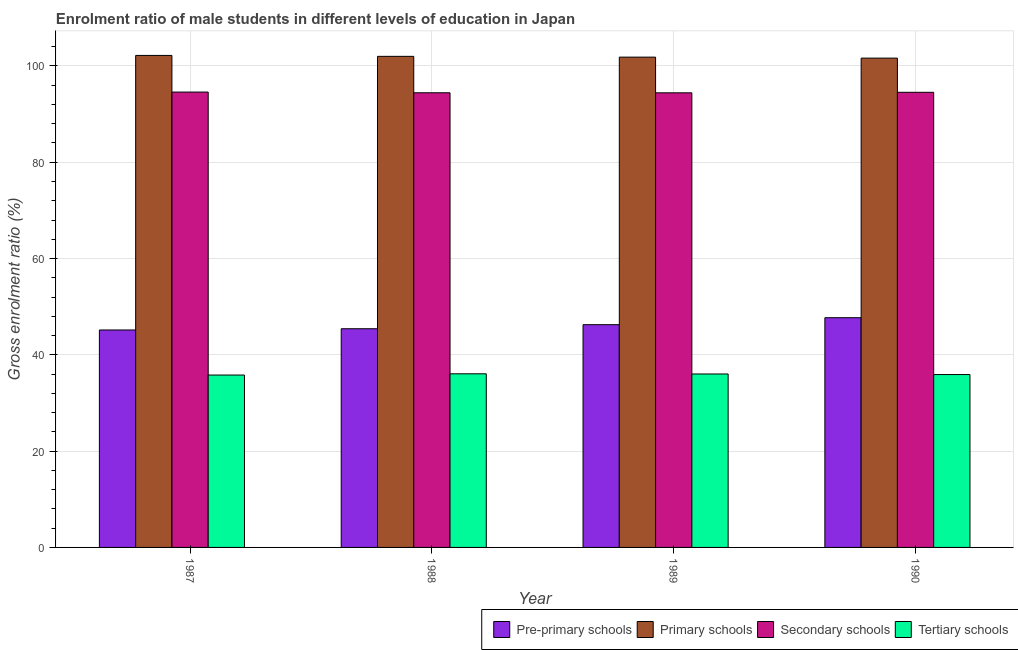How many groups of bars are there?
Ensure brevity in your answer.  4. Are the number of bars per tick equal to the number of legend labels?
Your answer should be compact. Yes. How many bars are there on the 3rd tick from the right?
Ensure brevity in your answer.  4. In how many cases, is the number of bars for a given year not equal to the number of legend labels?
Ensure brevity in your answer.  0. What is the gross enrolment ratio(female) in secondary schools in 1988?
Make the answer very short. 94.42. Across all years, what is the maximum gross enrolment ratio(female) in primary schools?
Provide a succinct answer. 102.18. Across all years, what is the minimum gross enrolment ratio(female) in tertiary schools?
Make the answer very short. 35.8. In which year was the gross enrolment ratio(female) in pre-primary schools minimum?
Offer a terse response. 1987. What is the total gross enrolment ratio(female) in primary schools in the graph?
Keep it short and to the point. 407.61. What is the difference between the gross enrolment ratio(female) in tertiary schools in 1988 and that in 1989?
Your answer should be very brief. 0.04. What is the difference between the gross enrolment ratio(female) in tertiary schools in 1988 and the gross enrolment ratio(female) in primary schools in 1987?
Your response must be concise. 0.26. What is the average gross enrolment ratio(female) in pre-primary schools per year?
Make the answer very short. 46.14. What is the ratio of the gross enrolment ratio(female) in tertiary schools in 1989 to that in 1990?
Make the answer very short. 1. Is the gross enrolment ratio(female) in secondary schools in 1987 less than that in 1988?
Offer a terse response. No. Is the difference between the gross enrolment ratio(female) in tertiary schools in 1989 and 1990 greater than the difference between the gross enrolment ratio(female) in primary schools in 1989 and 1990?
Ensure brevity in your answer.  No. What is the difference between the highest and the second highest gross enrolment ratio(female) in tertiary schools?
Ensure brevity in your answer.  0.04. What is the difference between the highest and the lowest gross enrolment ratio(female) in primary schools?
Ensure brevity in your answer.  0.56. Is the sum of the gross enrolment ratio(female) in tertiary schools in 1987 and 1988 greater than the maximum gross enrolment ratio(female) in primary schools across all years?
Your answer should be very brief. Yes. What does the 3rd bar from the left in 1987 represents?
Your answer should be very brief. Secondary schools. What does the 1st bar from the right in 1987 represents?
Give a very brief answer. Tertiary schools. Is it the case that in every year, the sum of the gross enrolment ratio(female) in pre-primary schools and gross enrolment ratio(female) in primary schools is greater than the gross enrolment ratio(female) in secondary schools?
Provide a succinct answer. Yes. Are all the bars in the graph horizontal?
Make the answer very short. No. How many years are there in the graph?
Provide a short and direct response. 4. What is the difference between two consecutive major ticks on the Y-axis?
Your answer should be very brief. 20. Are the values on the major ticks of Y-axis written in scientific E-notation?
Ensure brevity in your answer.  No. What is the title of the graph?
Your answer should be compact. Enrolment ratio of male students in different levels of education in Japan. What is the label or title of the Y-axis?
Your answer should be very brief. Gross enrolment ratio (%). What is the Gross enrolment ratio (%) in Pre-primary schools in 1987?
Provide a succinct answer. 45.16. What is the Gross enrolment ratio (%) of Primary schools in 1987?
Offer a very short reply. 102.18. What is the Gross enrolment ratio (%) in Secondary schools in 1987?
Make the answer very short. 94.57. What is the Gross enrolment ratio (%) in Tertiary schools in 1987?
Keep it short and to the point. 35.8. What is the Gross enrolment ratio (%) in Pre-primary schools in 1988?
Keep it short and to the point. 45.42. What is the Gross enrolment ratio (%) in Primary schools in 1988?
Keep it short and to the point. 101.99. What is the Gross enrolment ratio (%) in Secondary schools in 1988?
Offer a very short reply. 94.42. What is the Gross enrolment ratio (%) of Tertiary schools in 1988?
Make the answer very short. 36.06. What is the Gross enrolment ratio (%) in Pre-primary schools in 1989?
Offer a terse response. 46.26. What is the Gross enrolment ratio (%) of Primary schools in 1989?
Your response must be concise. 101.82. What is the Gross enrolment ratio (%) in Secondary schools in 1989?
Give a very brief answer. 94.41. What is the Gross enrolment ratio (%) of Tertiary schools in 1989?
Offer a terse response. 36.02. What is the Gross enrolment ratio (%) in Pre-primary schools in 1990?
Ensure brevity in your answer.  47.71. What is the Gross enrolment ratio (%) of Primary schools in 1990?
Your answer should be compact. 101.62. What is the Gross enrolment ratio (%) in Secondary schools in 1990?
Your answer should be very brief. 94.52. What is the Gross enrolment ratio (%) in Tertiary schools in 1990?
Make the answer very short. 35.9. Across all years, what is the maximum Gross enrolment ratio (%) of Pre-primary schools?
Provide a short and direct response. 47.71. Across all years, what is the maximum Gross enrolment ratio (%) in Primary schools?
Offer a very short reply. 102.18. Across all years, what is the maximum Gross enrolment ratio (%) of Secondary schools?
Ensure brevity in your answer.  94.57. Across all years, what is the maximum Gross enrolment ratio (%) of Tertiary schools?
Make the answer very short. 36.06. Across all years, what is the minimum Gross enrolment ratio (%) of Pre-primary schools?
Offer a very short reply. 45.16. Across all years, what is the minimum Gross enrolment ratio (%) in Primary schools?
Provide a succinct answer. 101.62. Across all years, what is the minimum Gross enrolment ratio (%) of Secondary schools?
Give a very brief answer. 94.41. Across all years, what is the minimum Gross enrolment ratio (%) of Tertiary schools?
Provide a succinct answer. 35.8. What is the total Gross enrolment ratio (%) in Pre-primary schools in the graph?
Keep it short and to the point. 184.54. What is the total Gross enrolment ratio (%) in Primary schools in the graph?
Provide a succinct answer. 407.61. What is the total Gross enrolment ratio (%) in Secondary schools in the graph?
Your answer should be very brief. 377.93. What is the total Gross enrolment ratio (%) of Tertiary schools in the graph?
Your response must be concise. 143.78. What is the difference between the Gross enrolment ratio (%) of Pre-primary schools in 1987 and that in 1988?
Your answer should be compact. -0.26. What is the difference between the Gross enrolment ratio (%) in Primary schools in 1987 and that in 1988?
Provide a succinct answer. 0.19. What is the difference between the Gross enrolment ratio (%) in Secondary schools in 1987 and that in 1988?
Ensure brevity in your answer.  0.15. What is the difference between the Gross enrolment ratio (%) in Tertiary schools in 1987 and that in 1988?
Provide a succinct answer. -0.26. What is the difference between the Gross enrolment ratio (%) of Pre-primary schools in 1987 and that in 1989?
Your answer should be compact. -1.1. What is the difference between the Gross enrolment ratio (%) in Primary schools in 1987 and that in 1989?
Ensure brevity in your answer.  0.36. What is the difference between the Gross enrolment ratio (%) of Secondary schools in 1987 and that in 1989?
Provide a succinct answer. 0.16. What is the difference between the Gross enrolment ratio (%) in Tertiary schools in 1987 and that in 1989?
Your response must be concise. -0.22. What is the difference between the Gross enrolment ratio (%) of Pre-primary schools in 1987 and that in 1990?
Make the answer very short. -2.55. What is the difference between the Gross enrolment ratio (%) in Primary schools in 1987 and that in 1990?
Provide a succinct answer. 0.56. What is the difference between the Gross enrolment ratio (%) in Secondary schools in 1987 and that in 1990?
Ensure brevity in your answer.  0.05. What is the difference between the Gross enrolment ratio (%) of Tertiary schools in 1987 and that in 1990?
Ensure brevity in your answer.  -0.1. What is the difference between the Gross enrolment ratio (%) of Pre-primary schools in 1988 and that in 1989?
Your answer should be very brief. -0.84. What is the difference between the Gross enrolment ratio (%) of Primary schools in 1988 and that in 1989?
Your response must be concise. 0.16. What is the difference between the Gross enrolment ratio (%) in Secondary schools in 1988 and that in 1989?
Offer a very short reply. 0.01. What is the difference between the Gross enrolment ratio (%) in Tertiary schools in 1988 and that in 1989?
Ensure brevity in your answer.  0.04. What is the difference between the Gross enrolment ratio (%) of Pre-primary schools in 1988 and that in 1990?
Your response must be concise. -2.29. What is the difference between the Gross enrolment ratio (%) of Primary schools in 1988 and that in 1990?
Ensure brevity in your answer.  0.37. What is the difference between the Gross enrolment ratio (%) of Secondary schools in 1988 and that in 1990?
Give a very brief answer. -0.1. What is the difference between the Gross enrolment ratio (%) in Tertiary schools in 1988 and that in 1990?
Your answer should be very brief. 0.15. What is the difference between the Gross enrolment ratio (%) in Pre-primary schools in 1989 and that in 1990?
Provide a short and direct response. -1.45. What is the difference between the Gross enrolment ratio (%) of Primary schools in 1989 and that in 1990?
Give a very brief answer. 0.2. What is the difference between the Gross enrolment ratio (%) in Secondary schools in 1989 and that in 1990?
Keep it short and to the point. -0.11. What is the difference between the Gross enrolment ratio (%) of Tertiary schools in 1989 and that in 1990?
Provide a short and direct response. 0.12. What is the difference between the Gross enrolment ratio (%) of Pre-primary schools in 1987 and the Gross enrolment ratio (%) of Primary schools in 1988?
Your answer should be compact. -56.83. What is the difference between the Gross enrolment ratio (%) in Pre-primary schools in 1987 and the Gross enrolment ratio (%) in Secondary schools in 1988?
Offer a very short reply. -49.26. What is the difference between the Gross enrolment ratio (%) in Pre-primary schools in 1987 and the Gross enrolment ratio (%) in Tertiary schools in 1988?
Make the answer very short. 9.1. What is the difference between the Gross enrolment ratio (%) in Primary schools in 1987 and the Gross enrolment ratio (%) in Secondary schools in 1988?
Offer a terse response. 7.76. What is the difference between the Gross enrolment ratio (%) in Primary schools in 1987 and the Gross enrolment ratio (%) in Tertiary schools in 1988?
Offer a very short reply. 66.12. What is the difference between the Gross enrolment ratio (%) in Secondary schools in 1987 and the Gross enrolment ratio (%) in Tertiary schools in 1988?
Your answer should be very brief. 58.51. What is the difference between the Gross enrolment ratio (%) of Pre-primary schools in 1987 and the Gross enrolment ratio (%) of Primary schools in 1989?
Keep it short and to the point. -56.66. What is the difference between the Gross enrolment ratio (%) of Pre-primary schools in 1987 and the Gross enrolment ratio (%) of Secondary schools in 1989?
Your response must be concise. -49.25. What is the difference between the Gross enrolment ratio (%) of Pre-primary schools in 1987 and the Gross enrolment ratio (%) of Tertiary schools in 1989?
Your answer should be very brief. 9.14. What is the difference between the Gross enrolment ratio (%) in Primary schools in 1987 and the Gross enrolment ratio (%) in Secondary schools in 1989?
Offer a very short reply. 7.77. What is the difference between the Gross enrolment ratio (%) of Primary schools in 1987 and the Gross enrolment ratio (%) of Tertiary schools in 1989?
Make the answer very short. 66.16. What is the difference between the Gross enrolment ratio (%) of Secondary schools in 1987 and the Gross enrolment ratio (%) of Tertiary schools in 1989?
Your answer should be very brief. 58.55. What is the difference between the Gross enrolment ratio (%) of Pre-primary schools in 1987 and the Gross enrolment ratio (%) of Primary schools in 1990?
Make the answer very short. -56.46. What is the difference between the Gross enrolment ratio (%) in Pre-primary schools in 1987 and the Gross enrolment ratio (%) in Secondary schools in 1990?
Ensure brevity in your answer.  -49.36. What is the difference between the Gross enrolment ratio (%) in Pre-primary schools in 1987 and the Gross enrolment ratio (%) in Tertiary schools in 1990?
Offer a very short reply. 9.26. What is the difference between the Gross enrolment ratio (%) in Primary schools in 1987 and the Gross enrolment ratio (%) in Secondary schools in 1990?
Make the answer very short. 7.66. What is the difference between the Gross enrolment ratio (%) of Primary schools in 1987 and the Gross enrolment ratio (%) of Tertiary schools in 1990?
Your response must be concise. 66.28. What is the difference between the Gross enrolment ratio (%) in Secondary schools in 1987 and the Gross enrolment ratio (%) in Tertiary schools in 1990?
Keep it short and to the point. 58.67. What is the difference between the Gross enrolment ratio (%) in Pre-primary schools in 1988 and the Gross enrolment ratio (%) in Primary schools in 1989?
Your response must be concise. -56.41. What is the difference between the Gross enrolment ratio (%) of Pre-primary schools in 1988 and the Gross enrolment ratio (%) of Secondary schools in 1989?
Give a very brief answer. -49. What is the difference between the Gross enrolment ratio (%) in Pre-primary schools in 1988 and the Gross enrolment ratio (%) in Tertiary schools in 1989?
Your answer should be very brief. 9.39. What is the difference between the Gross enrolment ratio (%) in Primary schools in 1988 and the Gross enrolment ratio (%) in Secondary schools in 1989?
Your answer should be very brief. 7.57. What is the difference between the Gross enrolment ratio (%) in Primary schools in 1988 and the Gross enrolment ratio (%) in Tertiary schools in 1989?
Your response must be concise. 65.96. What is the difference between the Gross enrolment ratio (%) of Secondary schools in 1988 and the Gross enrolment ratio (%) of Tertiary schools in 1989?
Give a very brief answer. 58.4. What is the difference between the Gross enrolment ratio (%) in Pre-primary schools in 1988 and the Gross enrolment ratio (%) in Primary schools in 1990?
Your answer should be very brief. -56.2. What is the difference between the Gross enrolment ratio (%) in Pre-primary schools in 1988 and the Gross enrolment ratio (%) in Secondary schools in 1990?
Ensure brevity in your answer.  -49.11. What is the difference between the Gross enrolment ratio (%) of Pre-primary schools in 1988 and the Gross enrolment ratio (%) of Tertiary schools in 1990?
Offer a terse response. 9.51. What is the difference between the Gross enrolment ratio (%) in Primary schools in 1988 and the Gross enrolment ratio (%) in Secondary schools in 1990?
Your answer should be compact. 7.46. What is the difference between the Gross enrolment ratio (%) of Primary schools in 1988 and the Gross enrolment ratio (%) of Tertiary schools in 1990?
Make the answer very short. 66.08. What is the difference between the Gross enrolment ratio (%) of Secondary schools in 1988 and the Gross enrolment ratio (%) of Tertiary schools in 1990?
Your response must be concise. 58.52. What is the difference between the Gross enrolment ratio (%) in Pre-primary schools in 1989 and the Gross enrolment ratio (%) in Primary schools in 1990?
Your answer should be very brief. -55.36. What is the difference between the Gross enrolment ratio (%) in Pre-primary schools in 1989 and the Gross enrolment ratio (%) in Secondary schools in 1990?
Provide a short and direct response. -48.26. What is the difference between the Gross enrolment ratio (%) in Pre-primary schools in 1989 and the Gross enrolment ratio (%) in Tertiary schools in 1990?
Your answer should be compact. 10.36. What is the difference between the Gross enrolment ratio (%) in Primary schools in 1989 and the Gross enrolment ratio (%) in Secondary schools in 1990?
Your response must be concise. 7.3. What is the difference between the Gross enrolment ratio (%) of Primary schools in 1989 and the Gross enrolment ratio (%) of Tertiary schools in 1990?
Your response must be concise. 65.92. What is the difference between the Gross enrolment ratio (%) in Secondary schools in 1989 and the Gross enrolment ratio (%) in Tertiary schools in 1990?
Offer a very short reply. 58.51. What is the average Gross enrolment ratio (%) in Pre-primary schools per year?
Provide a succinct answer. 46.14. What is the average Gross enrolment ratio (%) in Primary schools per year?
Provide a short and direct response. 101.9. What is the average Gross enrolment ratio (%) of Secondary schools per year?
Offer a terse response. 94.48. What is the average Gross enrolment ratio (%) of Tertiary schools per year?
Make the answer very short. 35.95. In the year 1987, what is the difference between the Gross enrolment ratio (%) in Pre-primary schools and Gross enrolment ratio (%) in Primary schools?
Your response must be concise. -57.02. In the year 1987, what is the difference between the Gross enrolment ratio (%) in Pre-primary schools and Gross enrolment ratio (%) in Secondary schools?
Your answer should be compact. -49.41. In the year 1987, what is the difference between the Gross enrolment ratio (%) in Pre-primary schools and Gross enrolment ratio (%) in Tertiary schools?
Your response must be concise. 9.36. In the year 1987, what is the difference between the Gross enrolment ratio (%) in Primary schools and Gross enrolment ratio (%) in Secondary schools?
Offer a terse response. 7.61. In the year 1987, what is the difference between the Gross enrolment ratio (%) in Primary schools and Gross enrolment ratio (%) in Tertiary schools?
Make the answer very short. 66.38. In the year 1987, what is the difference between the Gross enrolment ratio (%) in Secondary schools and Gross enrolment ratio (%) in Tertiary schools?
Give a very brief answer. 58.77. In the year 1988, what is the difference between the Gross enrolment ratio (%) of Pre-primary schools and Gross enrolment ratio (%) of Primary schools?
Give a very brief answer. -56.57. In the year 1988, what is the difference between the Gross enrolment ratio (%) in Pre-primary schools and Gross enrolment ratio (%) in Secondary schools?
Provide a succinct answer. -49.01. In the year 1988, what is the difference between the Gross enrolment ratio (%) in Pre-primary schools and Gross enrolment ratio (%) in Tertiary schools?
Ensure brevity in your answer.  9.36. In the year 1988, what is the difference between the Gross enrolment ratio (%) in Primary schools and Gross enrolment ratio (%) in Secondary schools?
Provide a succinct answer. 7.56. In the year 1988, what is the difference between the Gross enrolment ratio (%) in Primary schools and Gross enrolment ratio (%) in Tertiary schools?
Your answer should be compact. 65.93. In the year 1988, what is the difference between the Gross enrolment ratio (%) of Secondary schools and Gross enrolment ratio (%) of Tertiary schools?
Provide a succinct answer. 58.37. In the year 1989, what is the difference between the Gross enrolment ratio (%) in Pre-primary schools and Gross enrolment ratio (%) in Primary schools?
Your answer should be very brief. -55.56. In the year 1989, what is the difference between the Gross enrolment ratio (%) of Pre-primary schools and Gross enrolment ratio (%) of Secondary schools?
Offer a very short reply. -48.15. In the year 1989, what is the difference between the Gross enrolment ratio (%) in Pre-primary schools and Gross enrolment ratio (%) in Tertiary schools?
Keep it short and to the point. 10.24. In the year 1989, what is the difference between the Gross enrolment ratio (%) in Primary schools and Gross enrolment ratio (%) in Secondary schools?
Offer a very short reply. 7.41. In the year 1989, what is the difference between the Gross enrolment ratio (%) of Primary schools and Gross enrolment ratio (%) of Tertiary schools?
Provide a succinct answer. 65.8. In the year 1989, what is the difference between the Gross enrolment ratio (%) in Secondary schools and Gross enrolment ratio (%) in Tertiary schools?
Give a very brief answer. 58.39. In the year 1990, what is the difference between the Gross enrolment ratio (%) of Pre-primary schools and Gross enrolment ratio (%) of Primary schools?
Make the answer very short. -53.91. In the year 1990, what is the difference between the Gross enrolment ratio (%) in Pre-primary schools and Gross enrolment ratio (%) in Secondary schools?
Your answer should be compact. -46.81. In the year 1990, what is the difference between the Gross enrolment ratio (%) of Pre-primary schools and Gross enrolment ratio (%) of Tertiary schools?
Give a very brief answer. 11.81. In the year 1990, what is the difference between the Gross enrolment ratio (%) of Primary schools and Gross enrolment ratio (%) of Secondary schools?
Your response must be concise. 7.1. In the year 1990, what is the difference between the Gross enrolment ratio (%) in Primary schools and Gross enrolment ratio (%) in Tertiary schools?
Your answer should be compact. 65.72. In the year 1990, what is the difference between the Gross enrolment ratio (%) of Secondary schools and Gross enrolment ratio (%) of Tertiary schools?
Provide a short and direct response. 58.62. What is the ratio of the Gross enrolment ratio (%) of Pre-primary schools in 1987 to that in 1988?
Provide a succinct answer. 0.99. What is the ratio of the Gross enrolment ratio (%) in Secondary schools in 1987 to that in 1988?
Offer a very short reply. 1. What is the ratio of the Gross enrolment ratio (%) of Tertiary schools in 1987 to that in 1988?
Your answer should be compact. 0.99. What is the ratio of the Gross enrolment ratio (%) of Pre-primary schools in 1987 to that in 1989?
Ensure brevity in your answer.  0.98. What is the ratio of the Gross enrolment ratio (%) in Tertiary schools in 1987 to that in 1989?
Your answer should be compact. 0.99. What is the ratio of the Gross enrolment ratio (%) in Pre-primary schools in 1987 to that in 1990?
Provide a succinct answer. 0.95. What is the ratio of the Gross enrolment ratio (%) of Pre-primary schools in 1988 to that in 1989?
Offer a terse response. 0.98. What is the ratio of the Gross enrolment ratio (%) in Secondary schools in 1988 to that in 1989?
Your answer should be very brief. 1. What is the ratio of the Gross enrolment ratio (%) of Tertiary schools in 1988 to that in 1989?
Offer a terse response. 1. What is the ratio of the Gross enrolment ratio (%) in Pre-primary schools in 1988 to that in 1990?
Give a very brief answer. 0.95. What is the ratio of the Gross enrolment ratio (%) of Secondary schools in 1988 to that in 1990?
Provide a succinct answer. 1. What is the ratio of the Gross enrolment ratio (%) of Pre-primary schools in 1989 to that in 1990?
Make the answer very short. 0.97. What is the difference between the highest and the second highest Gross enrolment ratio (%) in Pre-primary schools?
Keep it short and to the point. 1.45. What is the difference between the highest and the second highest Gross enrolment ratio (%) in Primary schools?
Your answer should be compact. 0.19. What is the difference between the highest and the second highest Gross enrolment ratio (%) in Secondary schools?
Your answer should be compact. 0.05. What is the difference between the highest and the second highest Gross enrolment ratio (%) in Tertiary schools?
Provide a succinct answer. 0.04. What is the difference between the highest and the lowest Gross enrolment ratio (%) of Pre-primary schools?
Offer a terse response. 2.55. What is the difference between the highest and the lowest Gross enrolment ratio (%) of Primary schools?
Keep it short and to the point. 0.56. What is the difference between the highest and the lowest Gross enrolment ratio (%) in Secondary schools?
Your response must be concise. 0.16. What is the difference between the highest and the lowest Gross enrolment ratio (%) of Tertiary schools?
Offer a terse response. 0.26. 